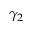<formula> <loc_0><loc_0><loc_500><loc_500>\gamma _ { 2 }</formula> 